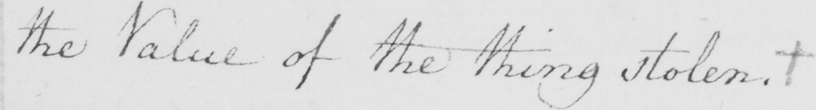What does this handwritten line say? the Value of the thing stolen .  + 